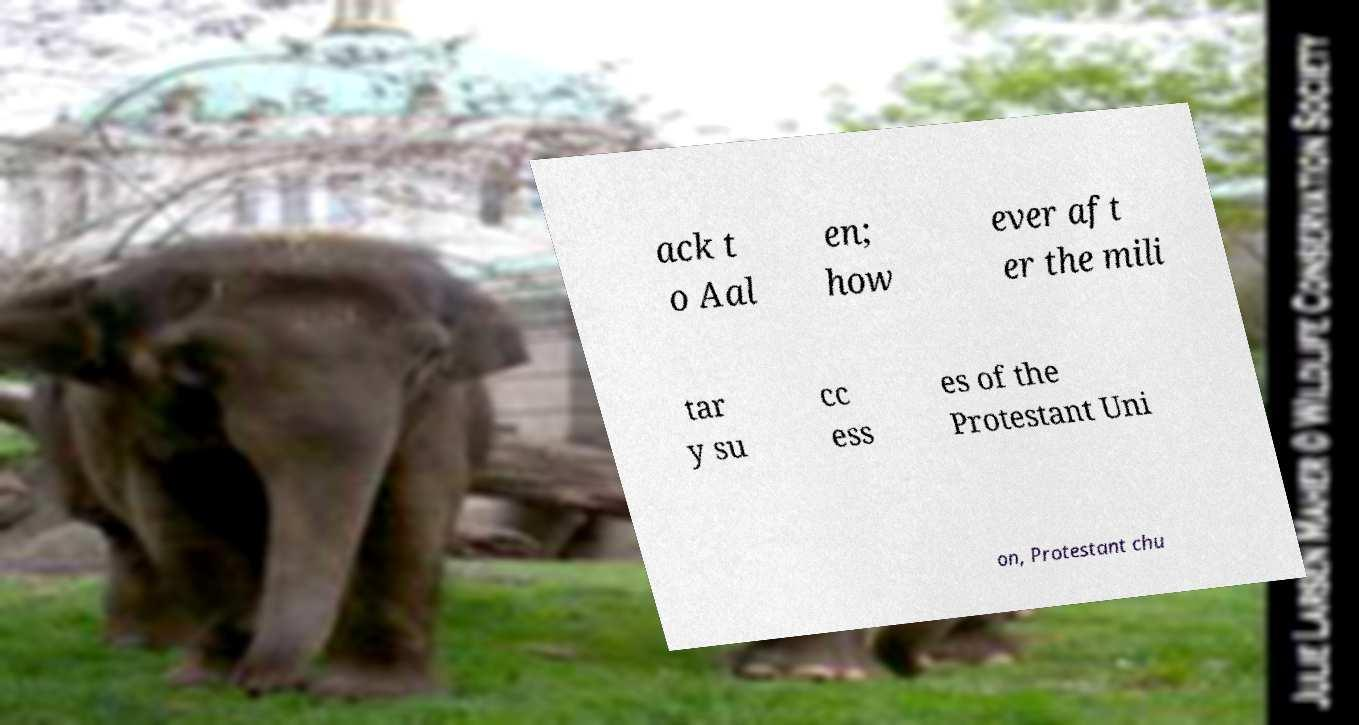I need the written content from this picture converted into text. Can you do that? ack t o Aal en; how ever aft er the mili tar y su cc ess es of the Protestant Uni on, Protestant chu 